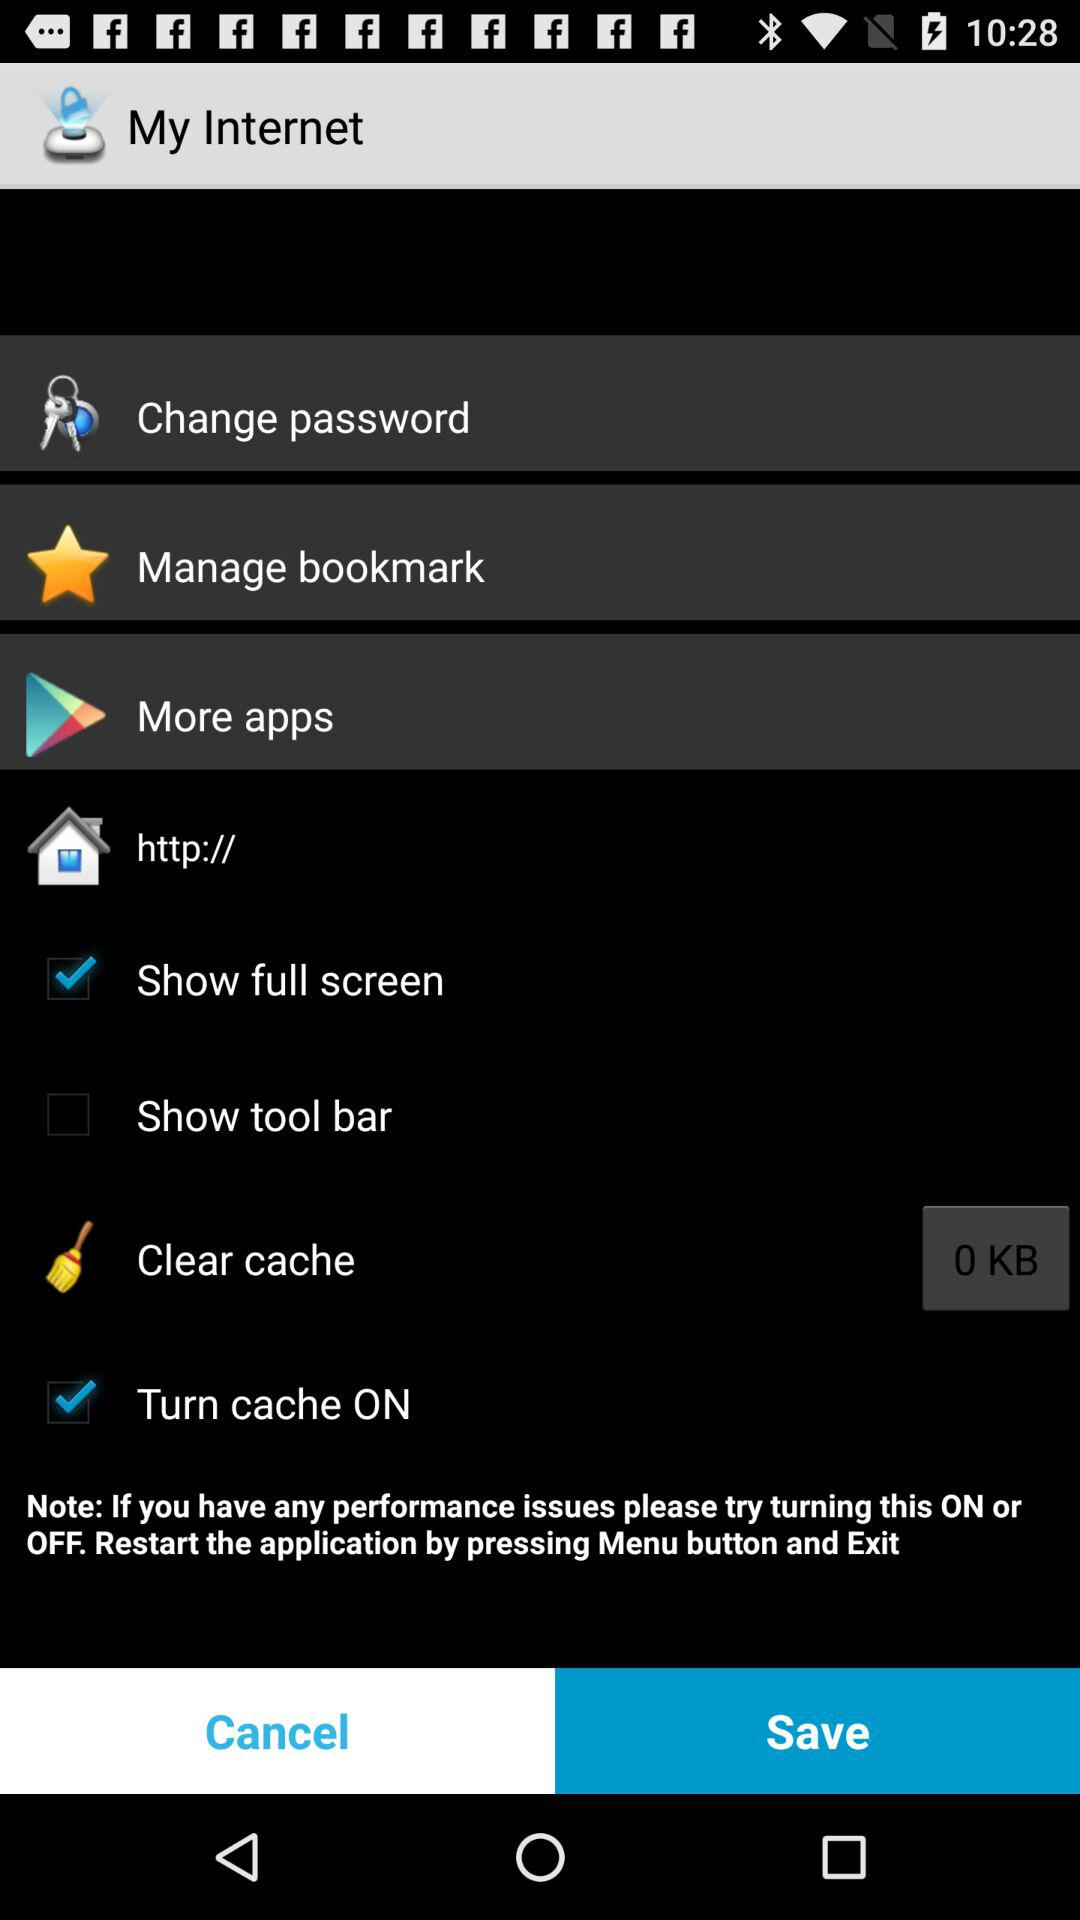How much cache can be cleared? The size of the cache that can be cleared is 0 KB. 